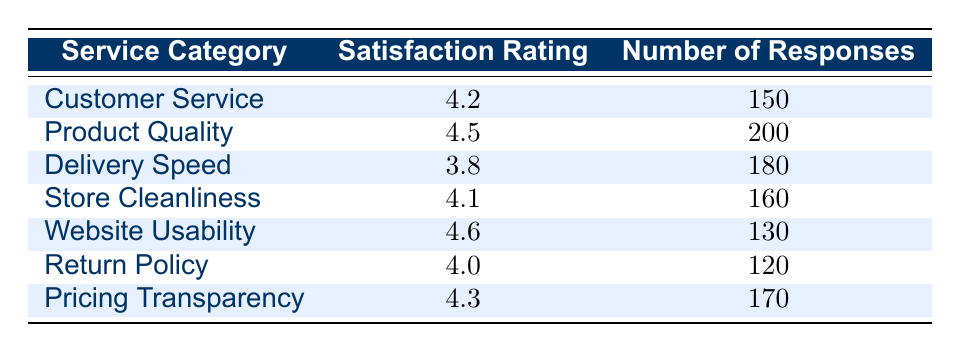What is the satisfaction rating for Product Quality? Referring to the table, the satisfaction rating for the "Product Quality" category is indicated directly as 4.5.
Answer: 4.5 Which service category has the highest satisfaction rating? Looking at the table, "Website Usability" has the highest satisfaction rating of 4.6 when compared with other service categories.
Answer: Website Usability How many total responses were recorded for Customer Service and Return Policy combined? The number of responses for "Customer Service" is 150 and for "Return Policy" is 120. Adding these together gives 150 + 120 = 270.
Answer: 270 Is the satisfaction rating for Delivery Speed greater than 4.0? The satisfaction rating for "Delivery Speed" is 3.8, which is less than 4.0. Therefore, the answer is no.
Answer: No What is the average satisfaction rating across all service categories? The satisfaction ratings are 4.2, 4.5, 3.8, 4.1, 4.6, 4.0, and 4.3. Summing these gives 29.5, and with 7 categories the average is 29.5 / 7 = 4.2142857, which can be rounded to 4.21.
Answer: 4.21 Which service category has the least number of responses? Checking the number of responses across all categories, "Website Usability" has the least with 130 responses, compared to others listed.
Answer: Website Usability Is there a service category with exactly 180 responses? Referring to the table, "Delivery Speed" has exactly 180 responses while other categories have different counts.
Answer: Yes What is the difference in satisfaction rating between the highest and lowest rated categories? The highest rating is 4.6 (Website Usability) and the lowest is 3.8 (Delivery Speed). The difference is 4.6 - 3.8 = 0.8.
Answer: 0.8 